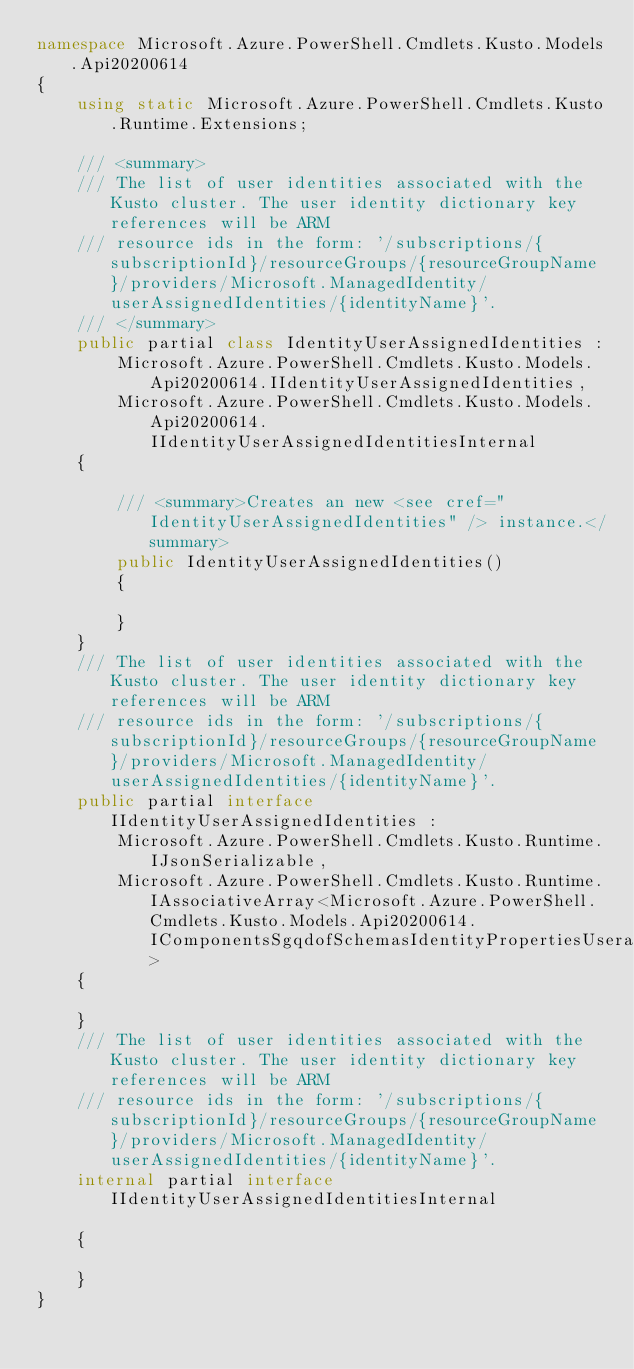Convert code to text. <code><loc_0><loc_0><loc_500><loc_500><_C#_>namespace Microsoft.Azure.PowerShell.Cmdlets.Kusto.Models.Api20200614
{
    using static Microsoft.Azure.PowerShell.Cmdlets.Kusto.Runtime.Extensions;

    /// <summary>
    /// The list of user identities associated with the Kusto cluster. The user identity dictionary key references will be ARM
    /// resource ids in the form: '/subscriptions/{subscriptionId}/resourceGroups/{resourceGroupName}/providers/Microsoft.ManagedIdentity/userAssignedIdentities/{identityName}'.
    /// </summary>
    public partial class IdentityUserAssignedIdentities :
        Microsoft.Azure.PowerShell.Cmdlets.Kusto.Models.Api20200614.IIdentityUserAssignedIdentities,
        Microsoft.Azure.PowerShell.Cmdlets.Kusto.Models.Api20200614.IIdentityUserAssignedIdentitiesInternal
    {

        /// <summary>Creates an new <see cref="IdentityUserAssignedIdentities" /> instance.</summary>
        public IdentityUserAssignedIdentities()
        {

        }
    }
    /// The list of user identities associated with the Kusto cluster. The user identity dictionary key references will be ARM
    /// resource ids in the form: '/subscriptions/{subscriptionId}/resourceGroups/{resourceGroupName}/providers/Microsoft.ManagedIdentity/userAssignedIdentities/{identityName}'.
    public partial interface IIdentityUserAssignedIdentities :
        Microsoft.Azure.PowerShell.Cmdlets.Kusto.Runtime.IJsonSerializable,
        Microsoft.Azure.PowerShell.Cmdlets.Kusto.Runtime.IAssociativeArray<Microsoft.Azure.PowerShell.Cmdlets.Kusto.Models.Api20200614.IComponentsSgqdofSchemasIdentityPropertiesUserassignedidentitiesAdditionalproperties>
    {

    }
    /// The list of user identities associated with the Kusto cluster. The user identity dictionary key references will be ARM
    /// resource ids in the form: '/subscriptions/{subscriptionId}/resourceGroups/{resourceGroupName}/providers/Microsoft.ManagedIdentity/userAssignedIdentities/{identityName}'.
    internal partial interface IIdentityUserAssignedIdentitiesInternal

    {

    }
}</code> 